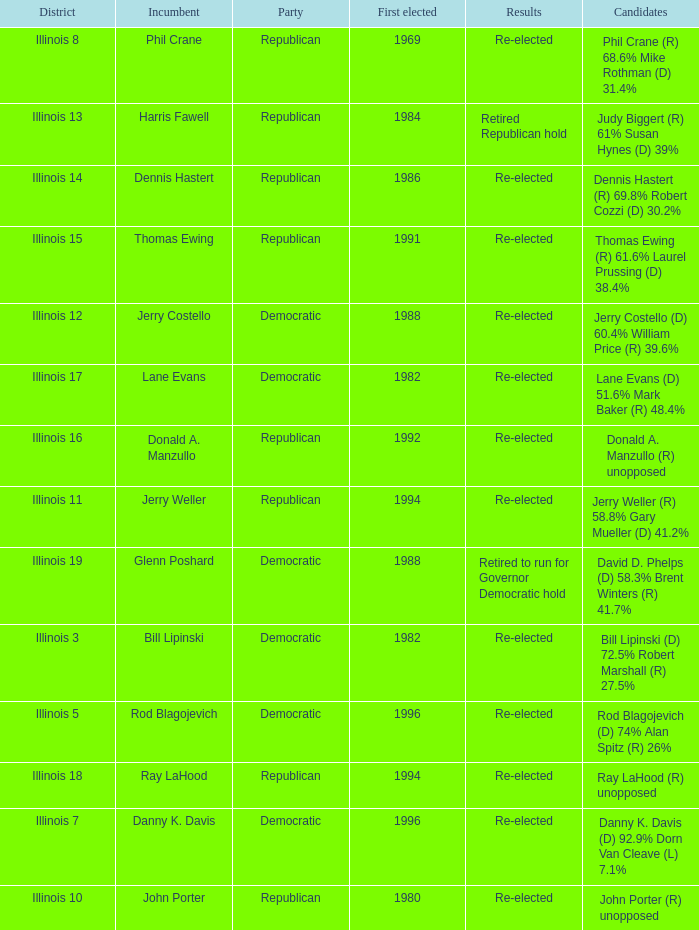What was the outcome in illinois 7? Re-elected. 